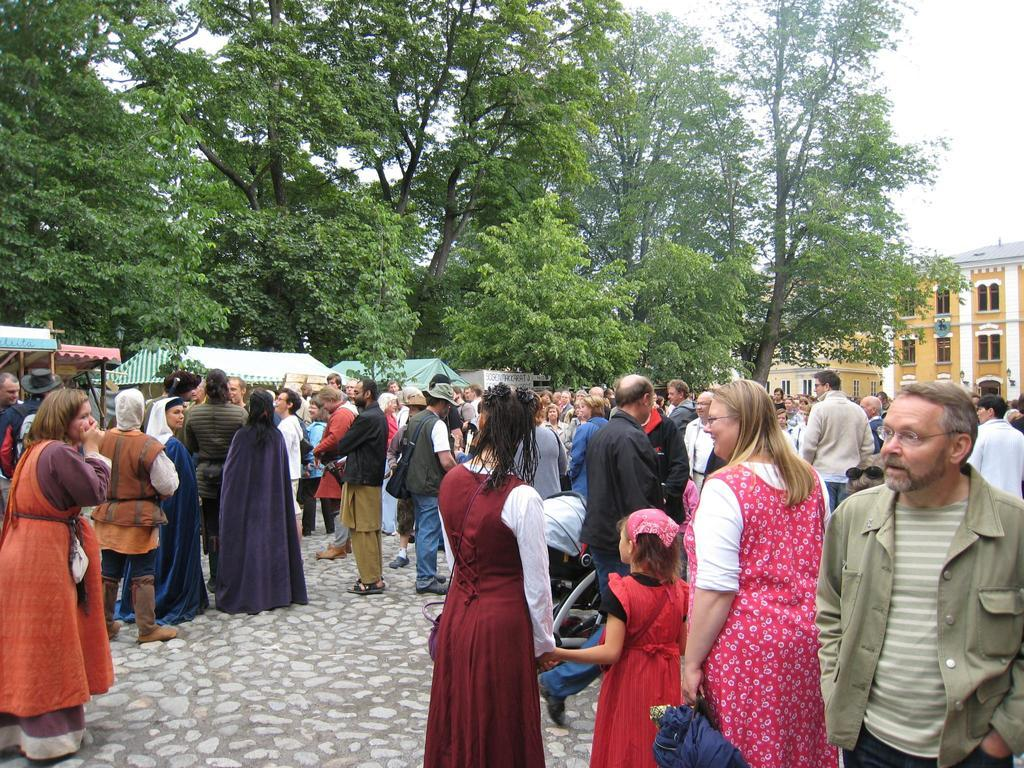What can be seen on the road in the image? There are persons in different color dresses on a road. What is visible in the background of the image? There are buildings, trees, shelters, and the sky in the background. What type of fang can be seen in the image? There are no fangs present in the image. What kind of lunch is being prepared by the persons in the image? The image does not show any lunch preparation or consumption; it only depicts persons standing on a road. 